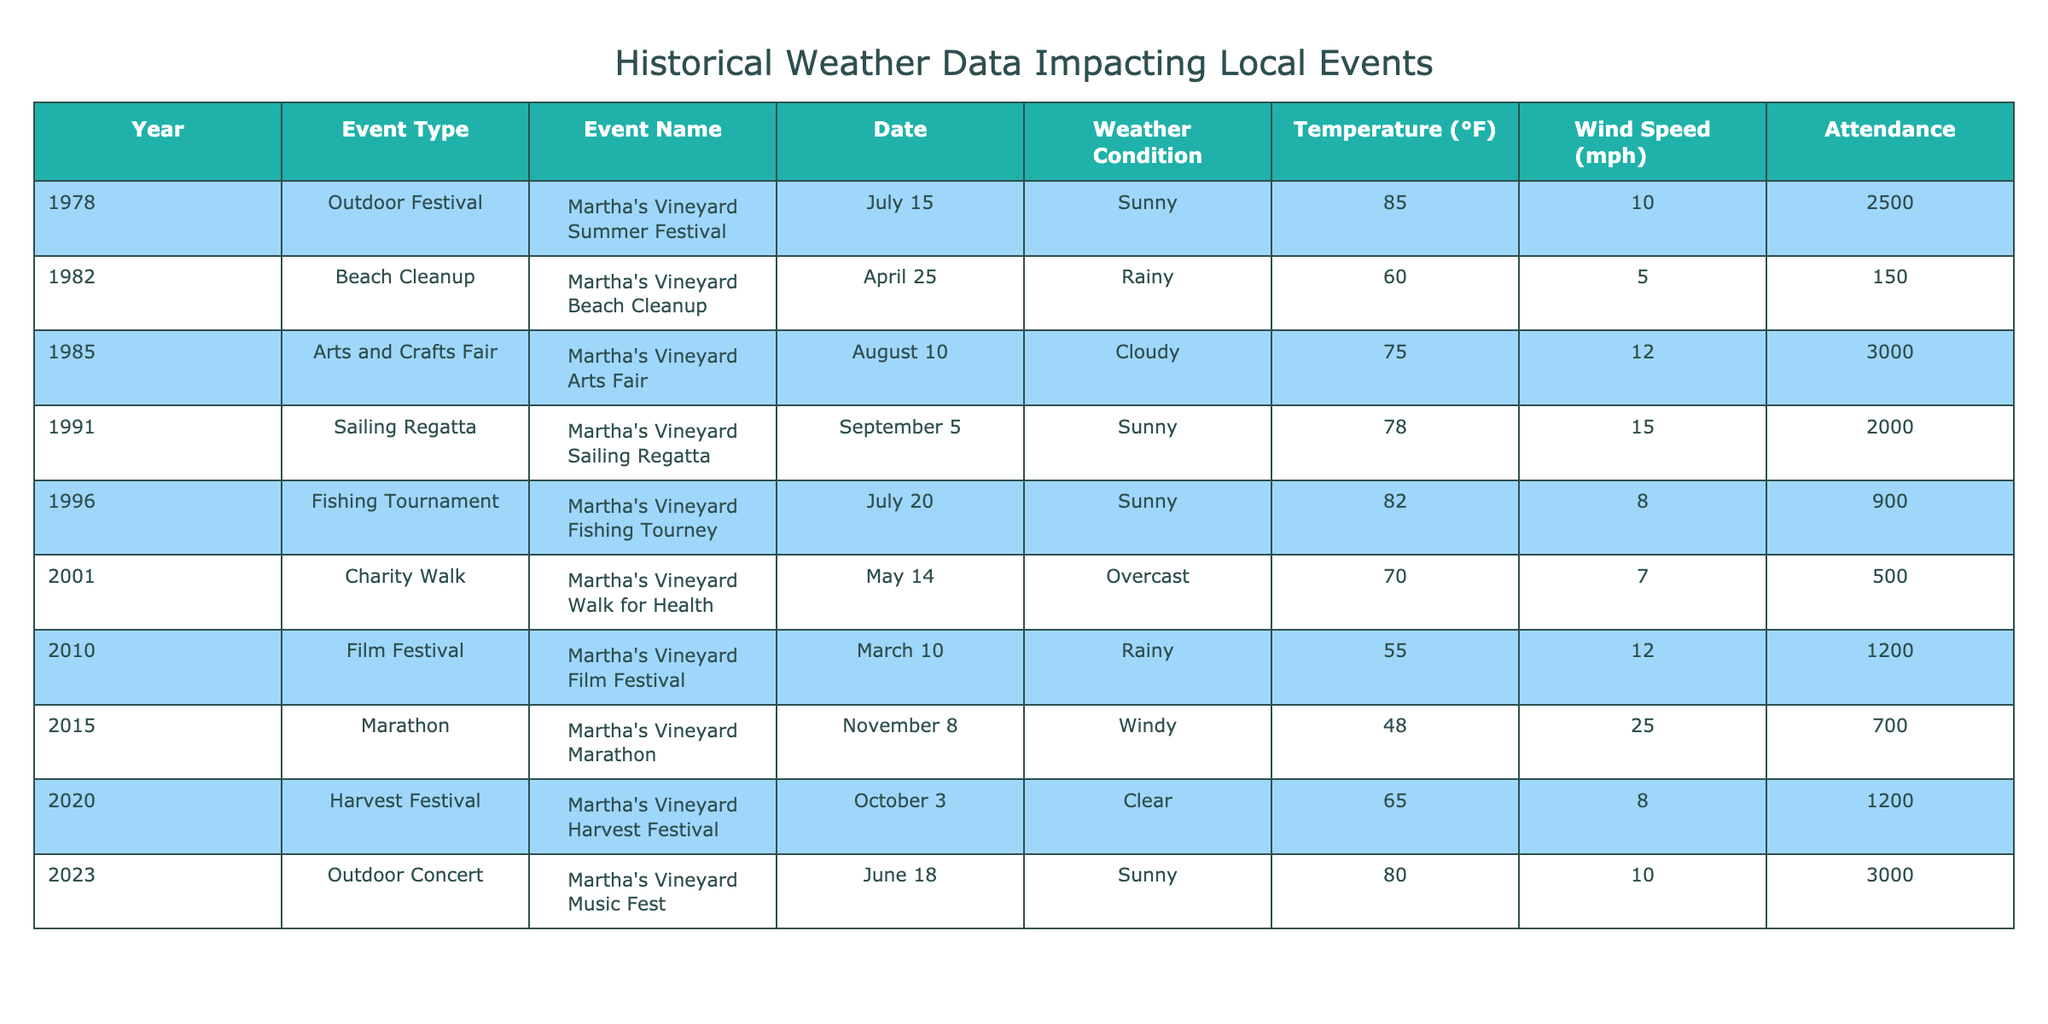What was the weather condition during the Martha's Vineyard Summer Festival in 1978? The table shows that the weather condition for the event held on July 15, 1978, was "Sunny."
Answer: Sunny How many attendees were recorded at the Martha's Vineyard Fishing Tourney in 1996? The event took place on July 20, 1996, and recorded 900 attendees according to the table.
Answer: 900 Which event in 2010 had the lowest attendance and what was the weather condition? Looking at the table, the Martha's Vineyard Film Festival in 2010 had the lowest attendance at 1200 with a weather condition that was "Rainy."
Answer: 1200 attendees, Rainy What is the average temperature of the events with 'Sunny' weather? The events with 'Sunny' weather are Summer Festival (85°F), Sailing Regatta (78°F), Fishing Tourney (82°F), and Outdoor Concert (80°F). Adding these temperatures gives 325°F, and dividing by 4 gives an average temperature of 81.25°F.
Answer: 81.25°F Were any events held during 'Rainy' weather conditions? The table indicates that there were two events held during 'Rainy' weather: the Beach Cleanup in 1982 and the Film Festival in 2010.
Answer: Yes How does the attendance of the Martha's Vineyard Marathon in 2015 compare to the Fishing Tournament in 1996? The Marathon in 2015 had an attendance of 700, while the Fishing Tournament in 1996 had 900 attendees. Therefore, the Fishing Tournament had higher attendance by 200 more people.
Answer: Fishing Tournament had higher attendance by 200 What was the weather condition at the Outdoor Concert in 2023 and how many attendees were there? The table indicates that the weather condition for the Outdoor Concert on June 18, 2023, was "Sunny" and that there were 3000 attendees.
Answer: Sunny, 3000 attendees Which event had the highest recorded wind speed and what was the attendance for that event? Examining the table shows that the Martha's Vineyard Marathon in 2015 had the highest wind speed recorded at 25 mph, while the attendance was 700 participants.
Answer: 25 mph, 700 attendees What is the difference in attendance between the Martha's Vineyard Arts Fair in 1985 and the Martha's Vineyard Walk for Health in 2001? The Arts Fair had 3000 attendees, while the Walk for Health had 500 attendees. The difference is 3000 minus 500, which equals 2500 attendees.
Answer: 2500 attendees difference 